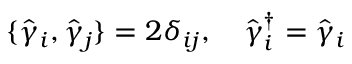<formula> <loc_0><loc_0><loc_500><loc_500>\{ \hat { \gamma } _ { i } , \hat { \gamma } _ { j } \} = 2 { \delta } _ { i j } , \quad h a t { \gamma } _ { i } ^ { \dagger } = \hat { \gamma } _ { i }</formula> 